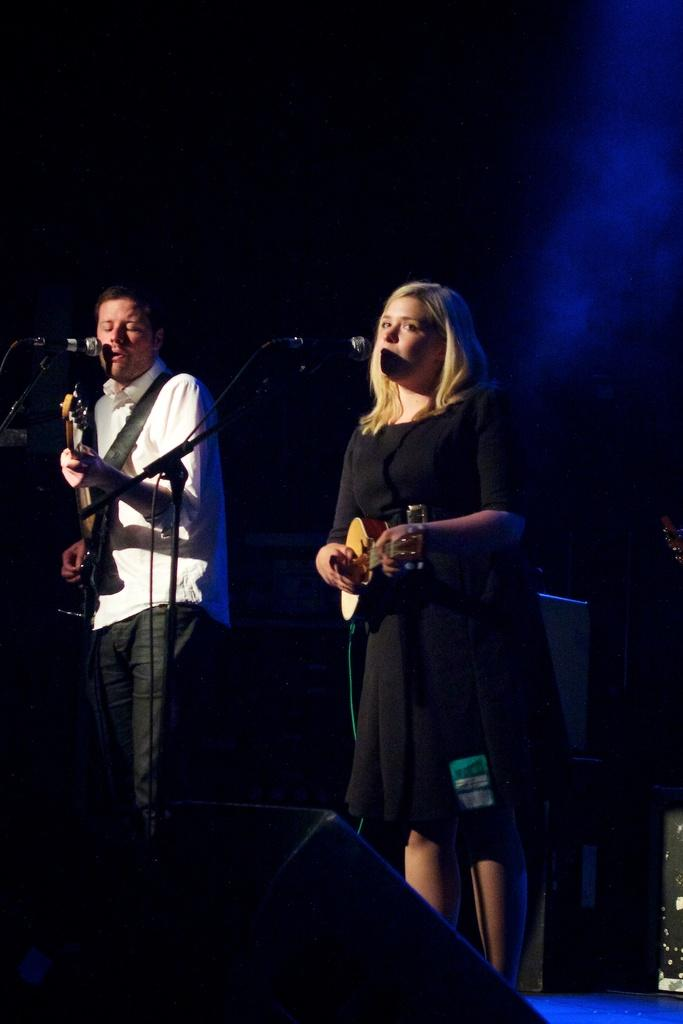Who is the main subject in the image? There is a girl in the image. What is the girl holding in the image? The girl is holding a guitar. What is the girl doing with the guitar? The girl is playing the guitar. Are there any other people in the image? Yes, there is a man in the image. What is the man doing in the image? The man is playing the guitar and singing. What type of building can be seen in the background of the image? There is no building visible in the image; it features a girl and a man playing and singing with guitars. 